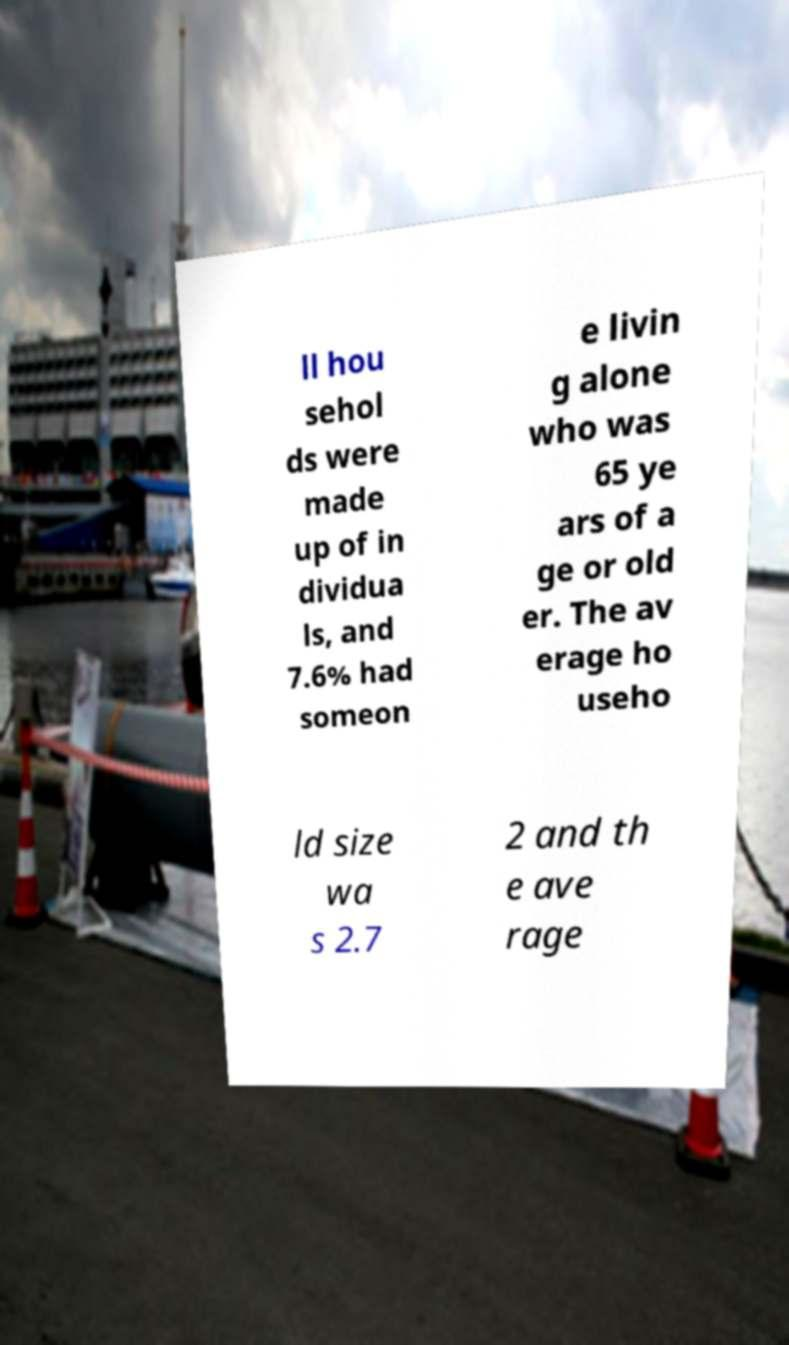Can you read and provide the text displayed in the image?This photo seems to have some interesting text. Can you extract and type it out for me? ll hou sehol ds were made up of in dividua ls, and 7.6% had someon e livin g alone who was 65 ye ars of a ge or old er. The av erage ho useho ld size wa s 2.7 2 and th e ave rage 